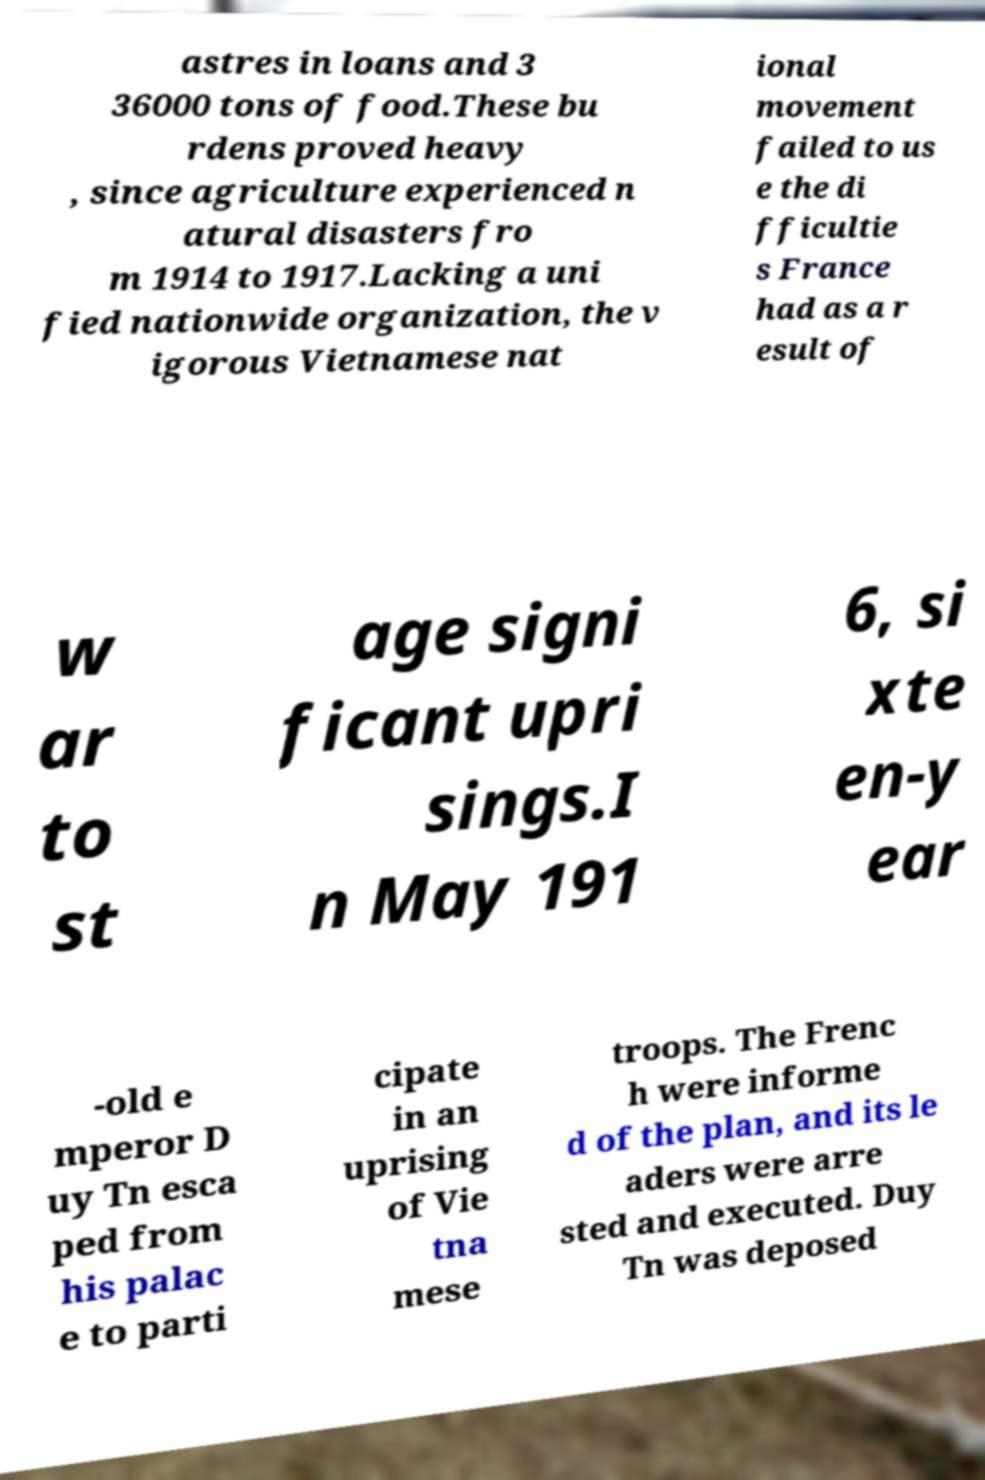I need the written content from this picture converted into text. Can you do that? astres in loans and 3 36000 tons of food.These bu rdens proved heavy , since agriculture experienced n atural disasters fro m 1914 to 1917.Lacking a uni fied nationwide organization, the v igorous Vietnamese nat ional movement failed to us e the di fficultie s France had as a r esult of w ar to st age signi ficant upri sings.I n May 191 6, si xte en-y ear -old e mperor D uy Tn esca ped from his palac e to parti cipate in an uprising of Vie tna mese troops. The Frenc h were informe d of the plan, and its le aders were arre sted and executed. Duy Tn was deposed 